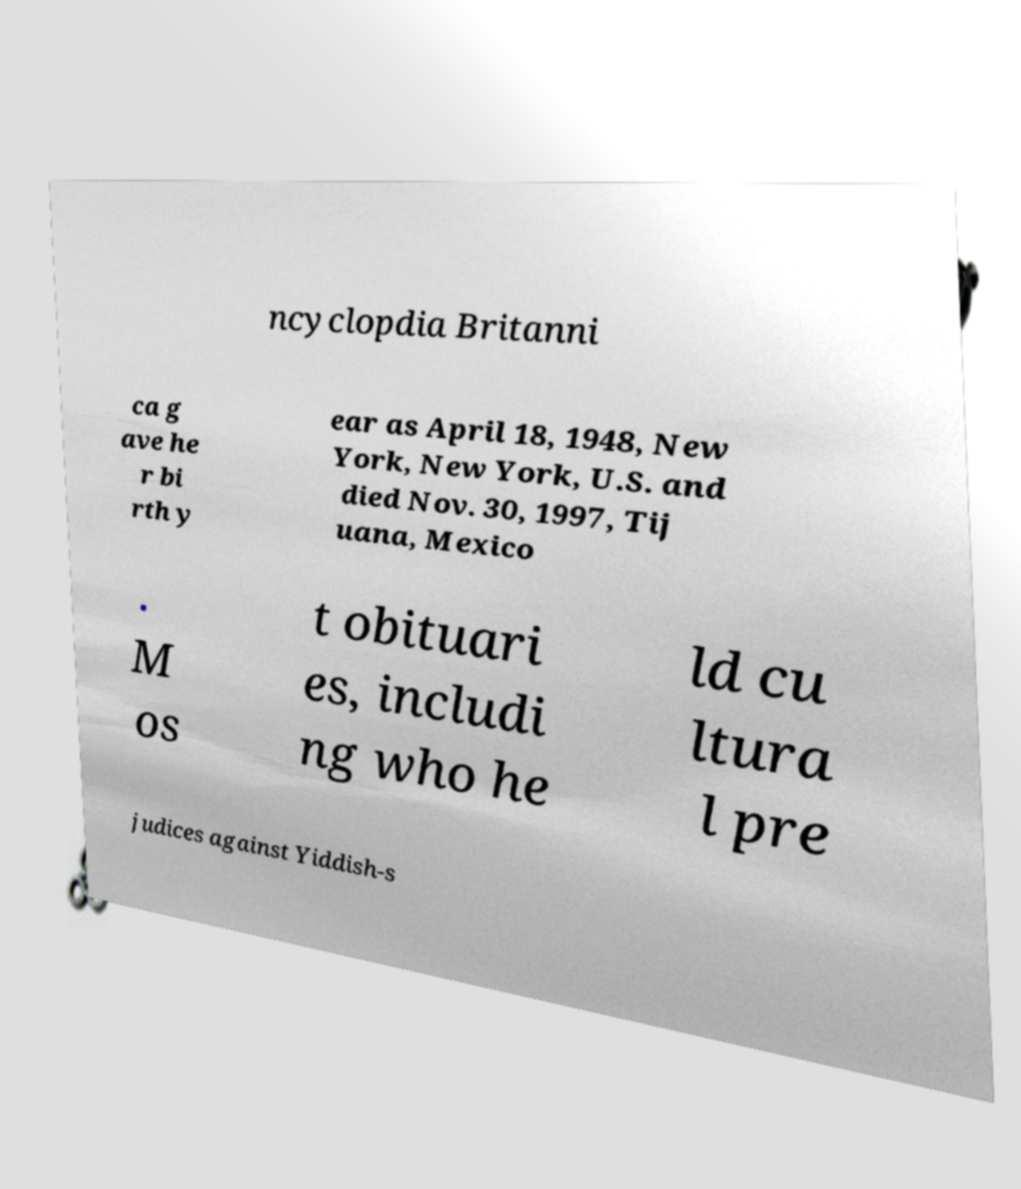Could you extract and type out the text from this image? ncyclopdia Britanni ca g ave he r bi rth y ear as April 18, 1948, New York, New York, U.S. and died Nov. 30, 1997, Tij uana, Mexico . M os t obituari es, includi ng who he ld cu ltura l pre judices against Yiddish-s 